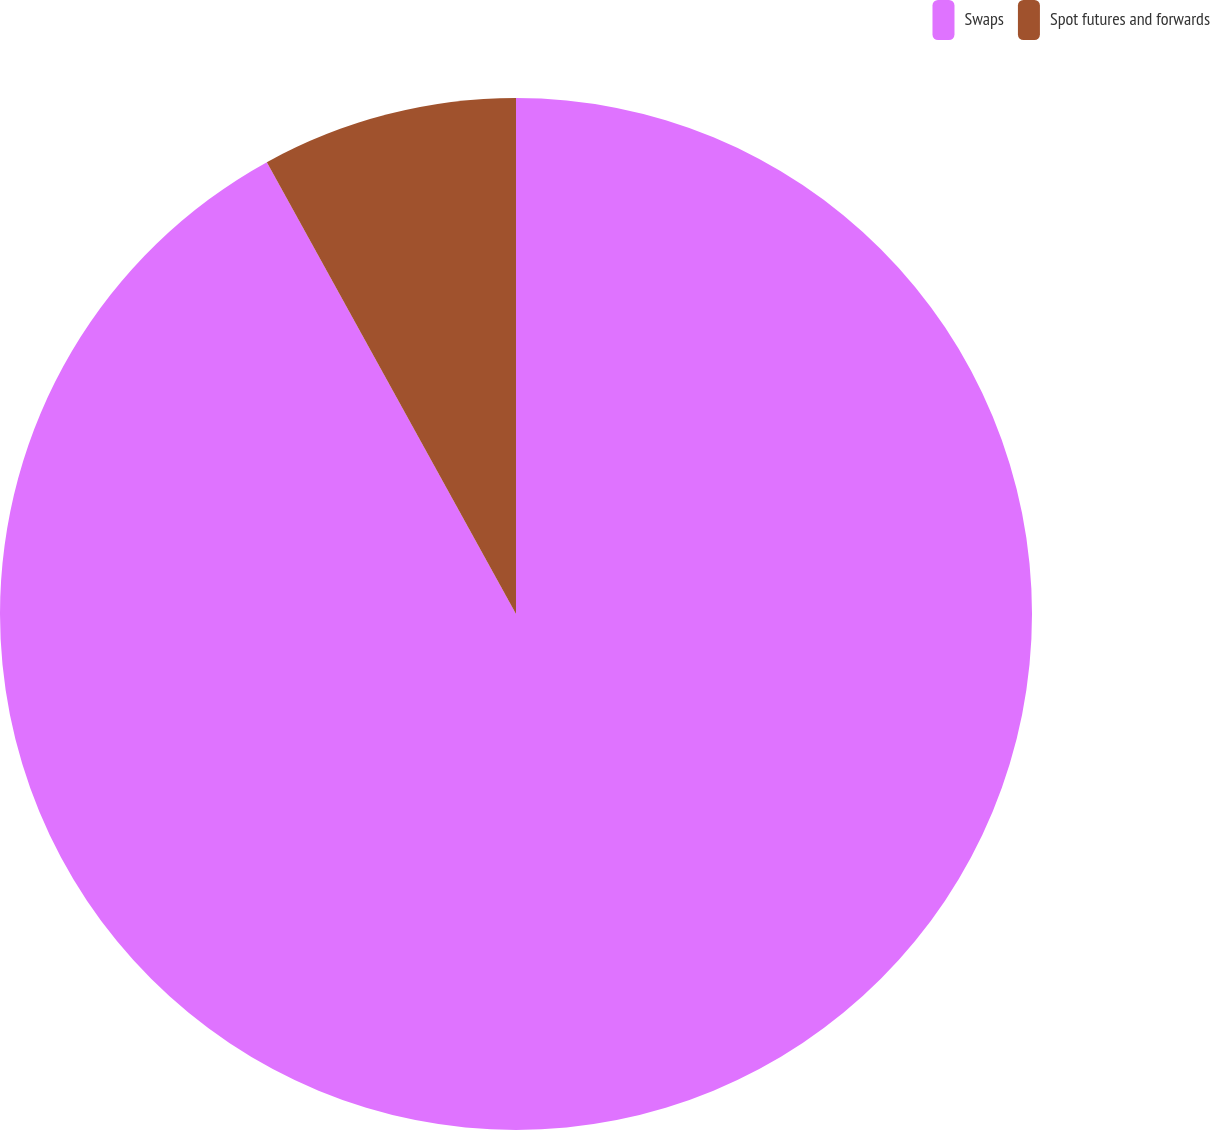Convert chart. <chart><loc_0><loc_0><loc_500><loc_500><pie_chart><fcel>Swaps<fcel>Spot futures and forwards<nl><fcel>91.98%<fcel>8.02%<nl></chart> 